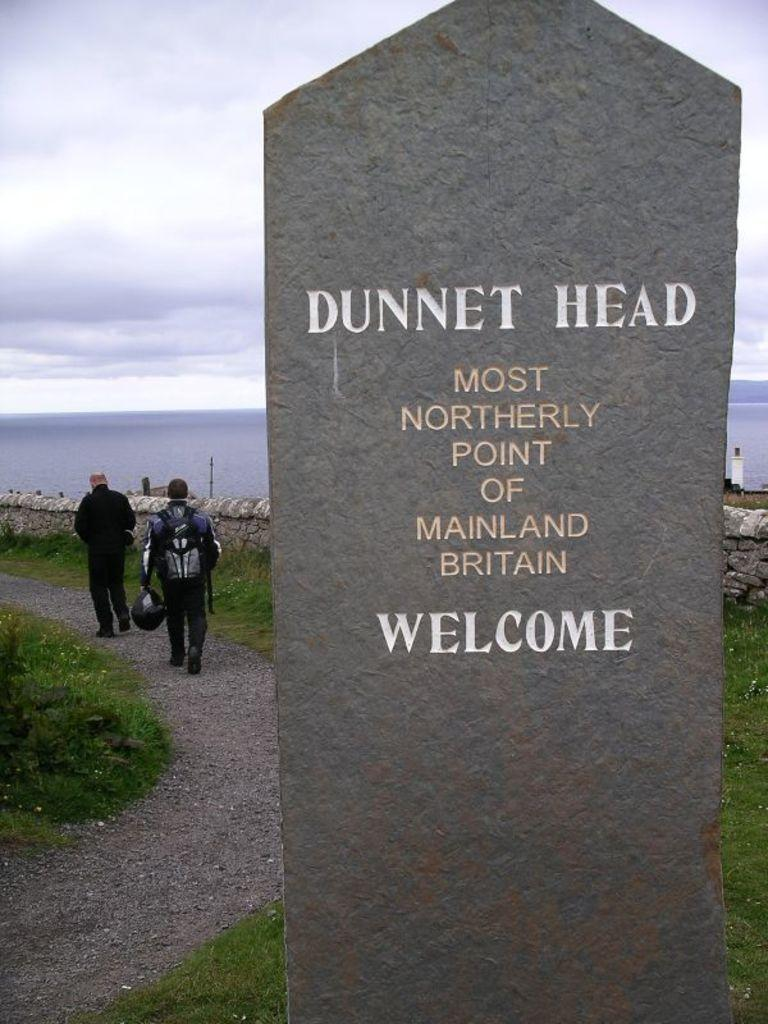What are the people in the image doing? The people in the image are walking on a path. What is the path surrounded by? The path is surrounded by grass. What can be seen on the board in the image? There is a board with text in the image. What is visible behind the wall in the image? Water is visible behind the wall. What type of butter is being used by the people walking on the path in the image? There is no butter present in the image; the people are walking on a path surrounded by grass. 